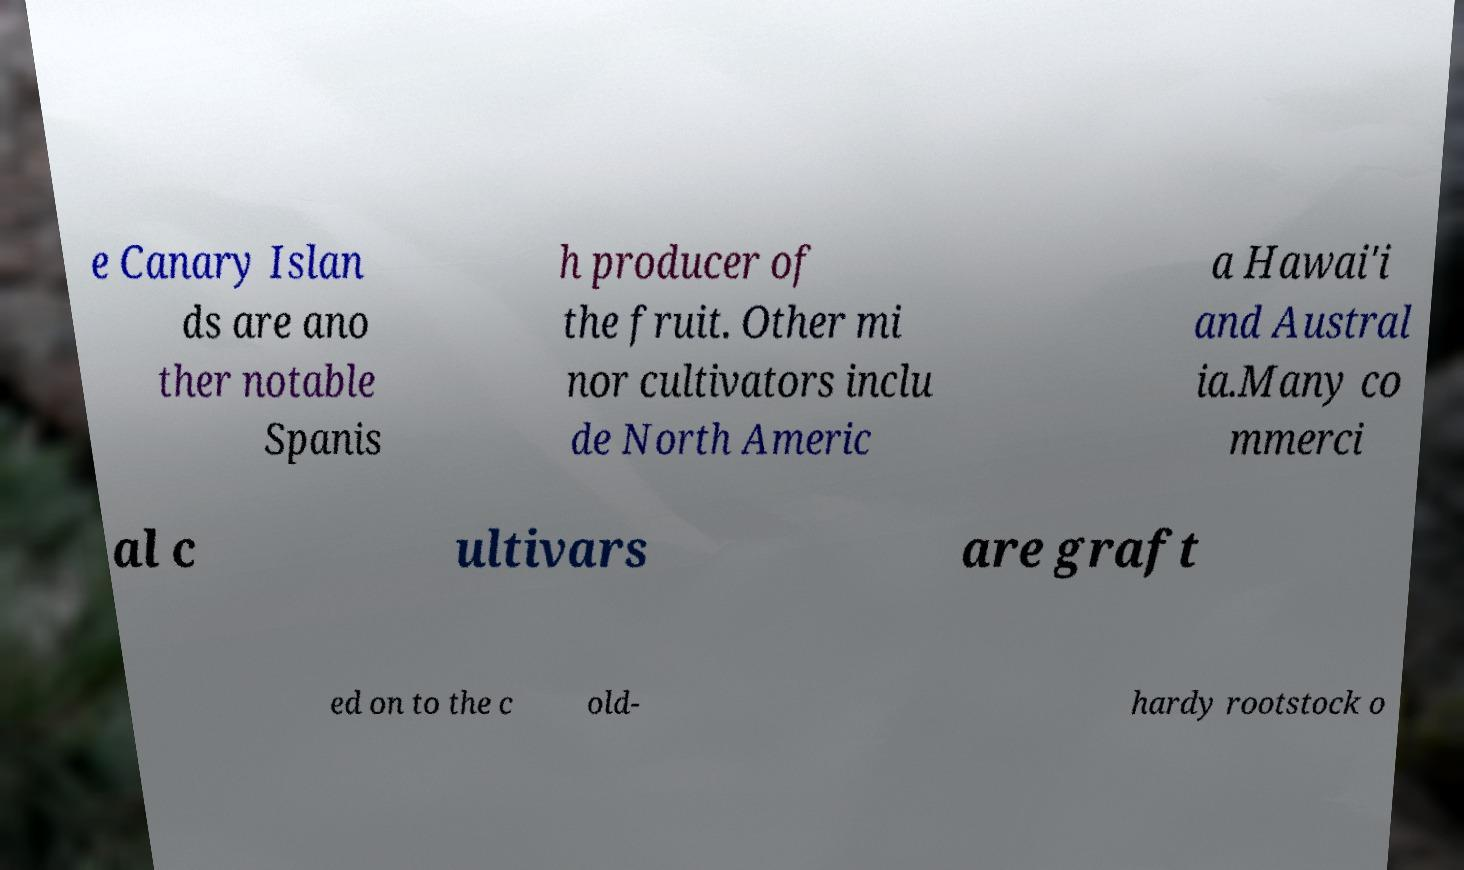I need the written content from this picture converted into text. Can you do that? e Canary Islan ds are ano ther notable Spanis h producer of the fruit. Other mi nor cultivators inclu de North Americ a Hawai'i and Austral ia.Many co mmerci al c ultivars are graft ed on to the c old- hardy rootstock o 